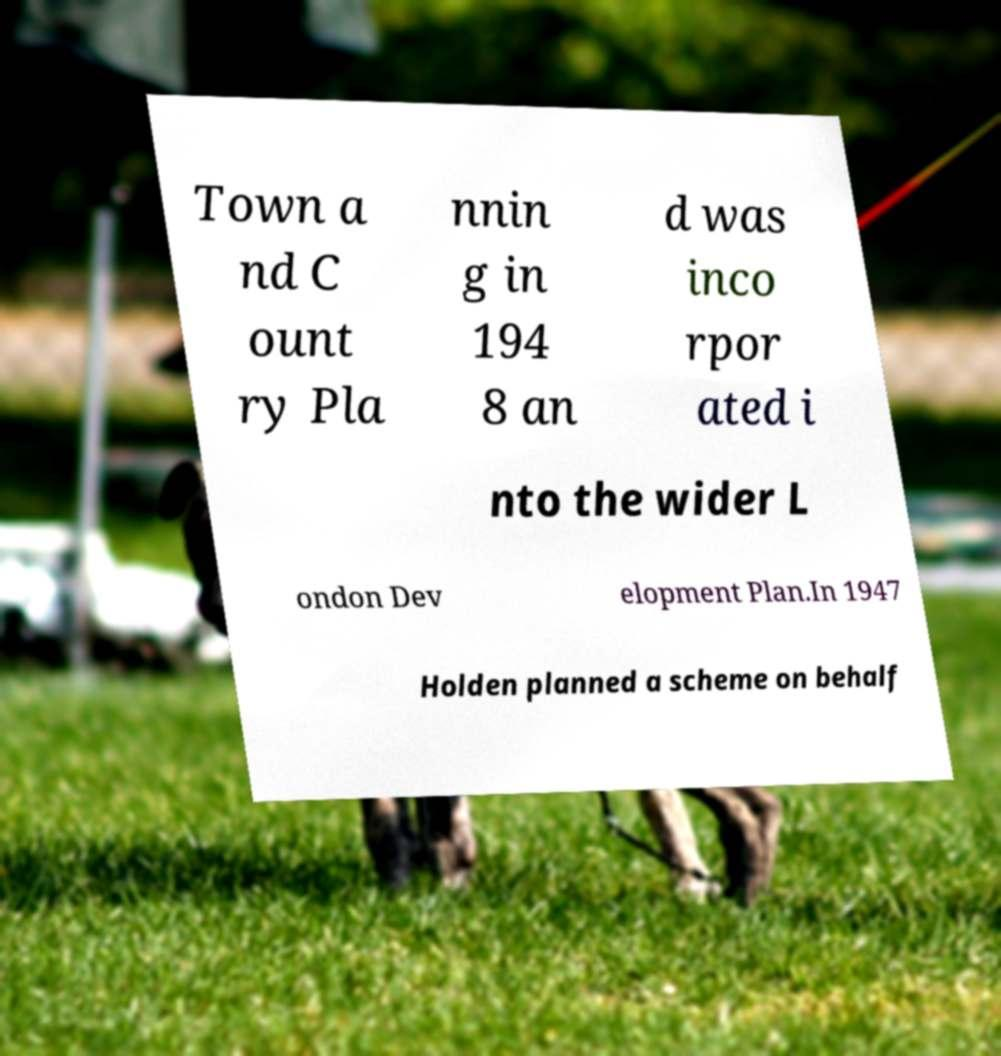Please identify and transcribe the text found in this image. Town a nd C ount ry Pla nnin g in 194 8 an d was inco rpor ated i nto the wider L ondon Dev elopment Plan.In 1947 Holden planned a scheme on behalf 